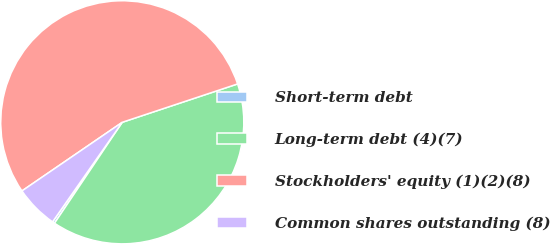Convert chart. <chart><loc_0><loc_0><loc_500><loc_500><pie_chart><fcel>Short-term debt<fcel>Long-term debt (4)(7)<fcel>Stockholders' equity (1)(2)(8)<fcel>Common shares outstanding (8)<nl><fcel>0.31%<fcel>39.52%<fcel>54.44%<fcel>5.73%<nl></chart> 